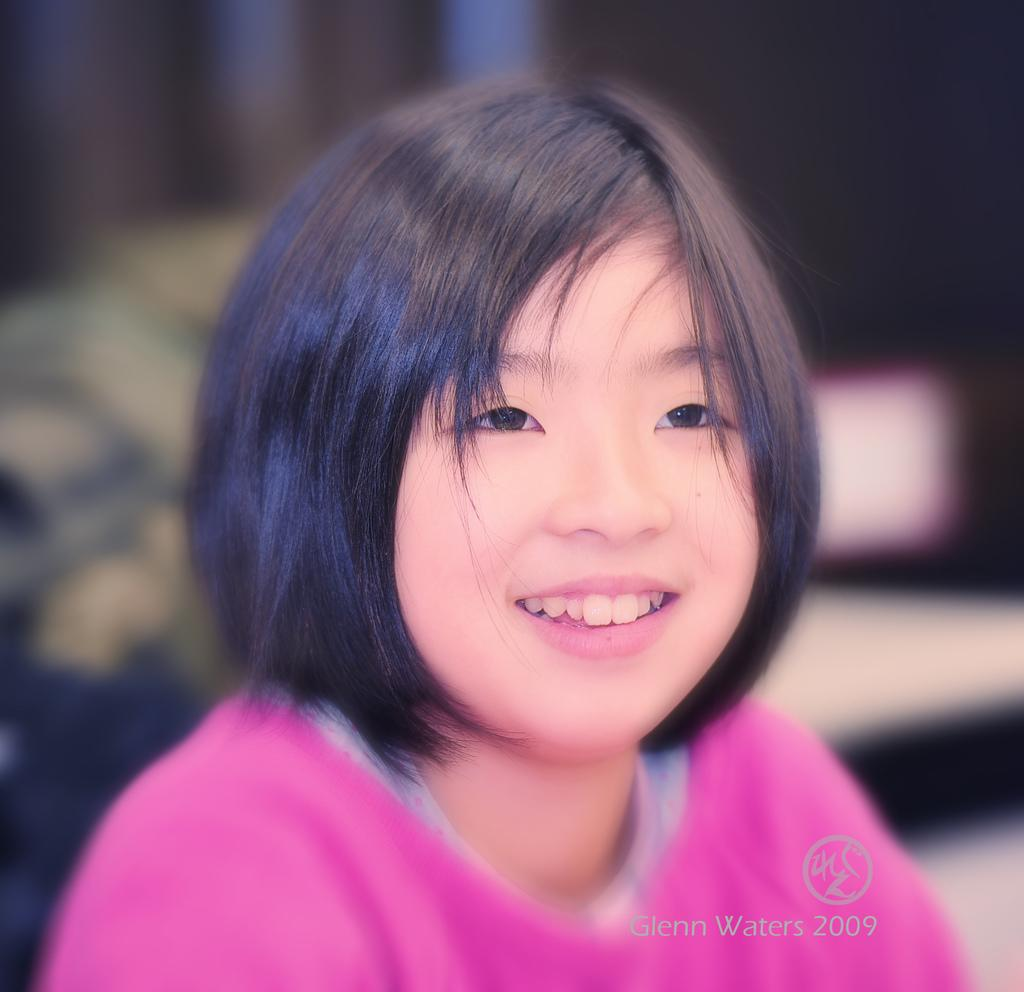Who is the main subject in the image? There is a girl in the image. What is the girl wearing? The girl is wearing a pink dress. What is the girl's facial expression in the image? The girl is smiling. In which direction is the girl looking? The girl is looking to the right side. What type of pin can be seen holding the girl's dress together in the image? There is no pin visible in the image; the girl is wearing a dress, but no pin is mentioned in the provided facts. 